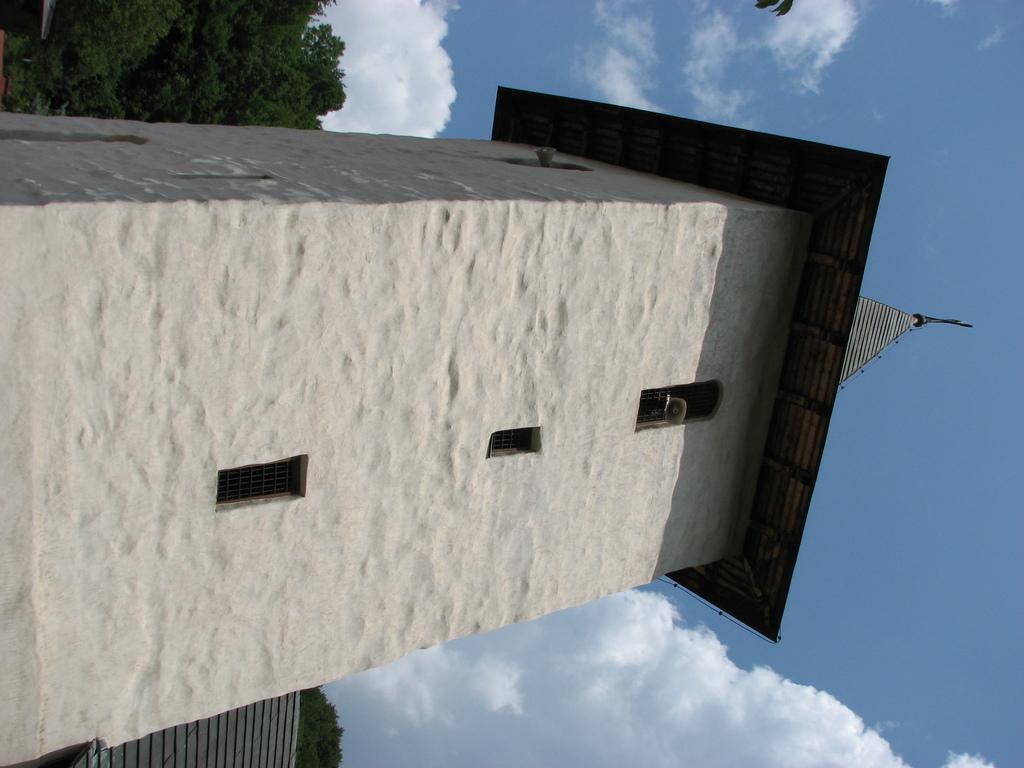Describe this image in one or two sentences. In the picture we can see a tower building construction and behind it, we can see trees, sky with clouds. 